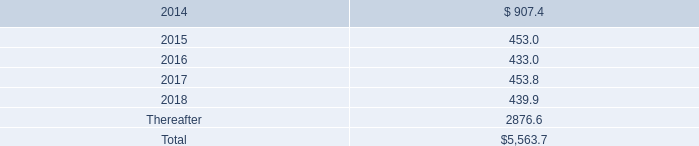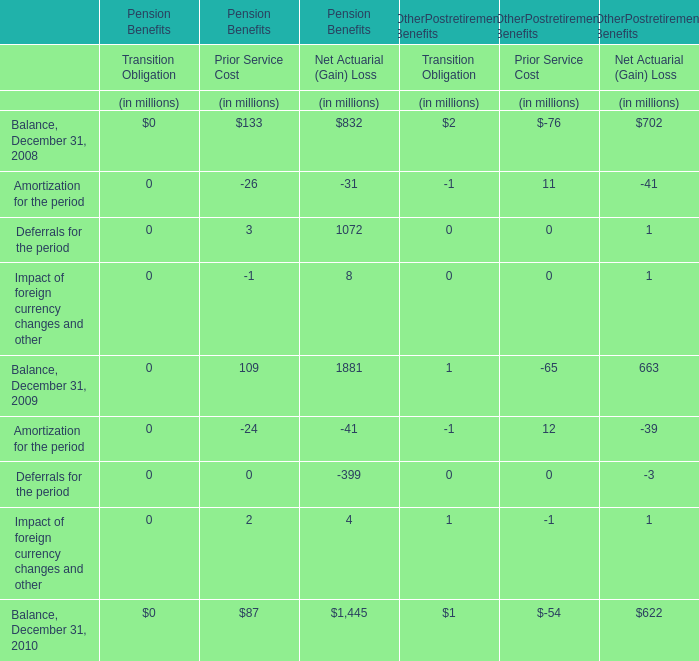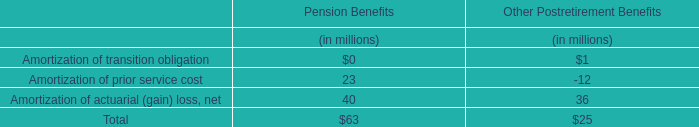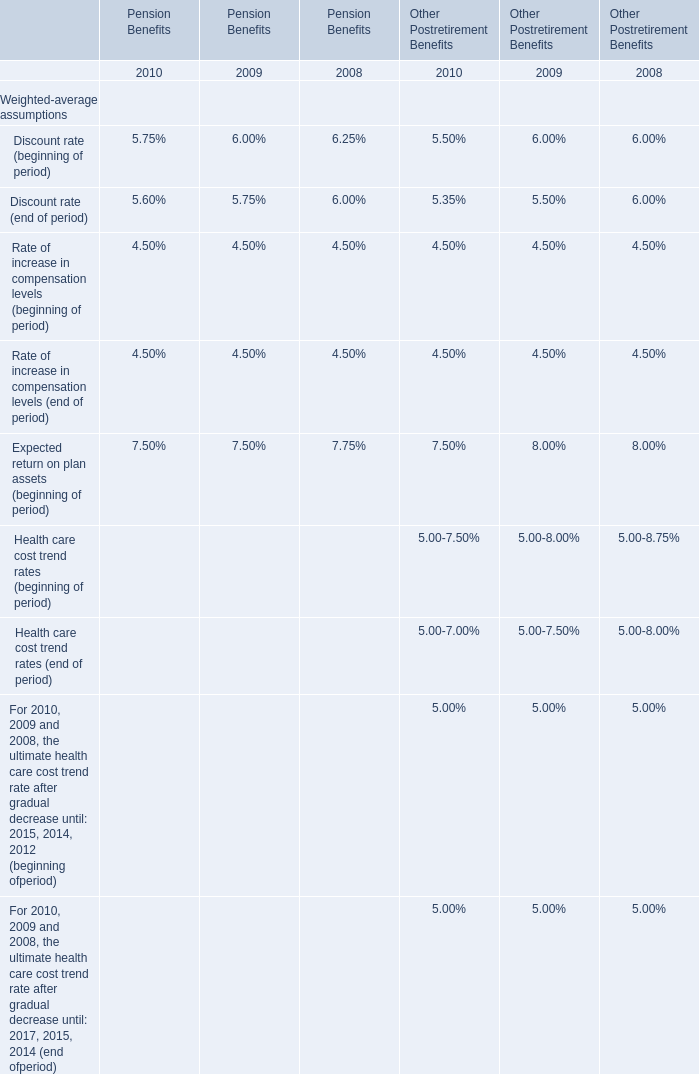What is the growth rate of Balance for Net Actuarial (Gain) in terms of Pension Benefits on December 31 between 2008 and 2009? 
Computations: ((1881 - 832) / 832)
Answer: 1.26082. 